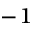<formula> <loc_0><loc_0><loc_500><loc_500>^ { - 1 }</formula> 